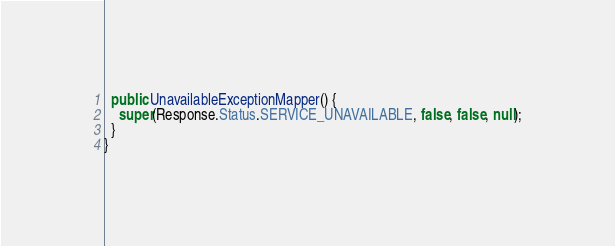<code> <loc_0><loc_0><loc_500><loc_500><_Java_>  public UnavailableExceptionMapper() {
    super(Response.Status.SERVICE_UNAVAILABLE, false, false, null);
  }
}
</code> 